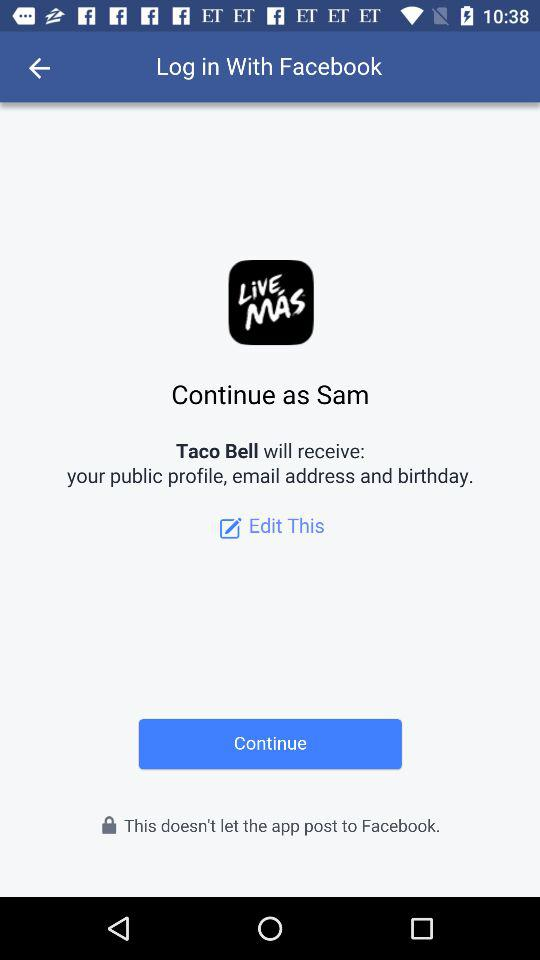Through what application can the user log in? The user can log in through "Facebook". 